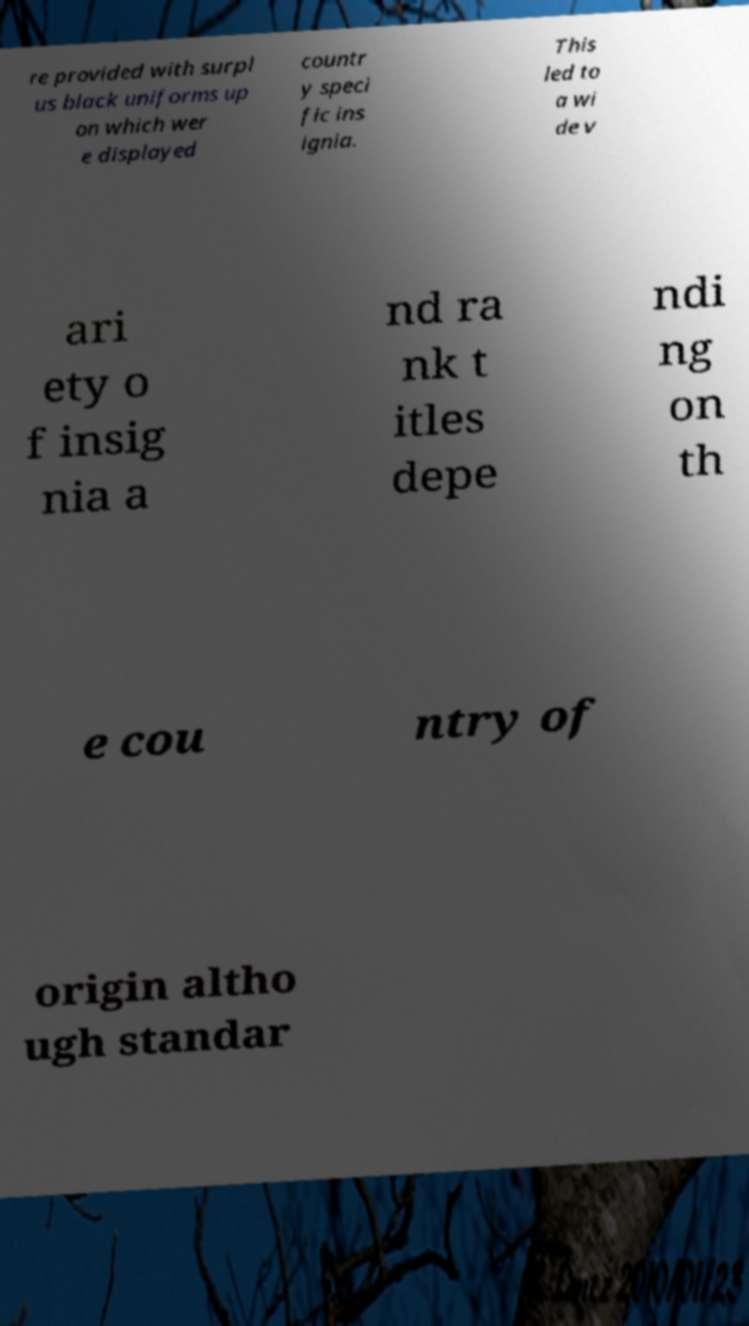What messages or text are displayed in this image? I need them in a readable, typed format. re provided with surpl us black uniforms up on which wer e displayed countr y speci fic ins ignia. This led to a wi de v ari ety o f insig nia a nd ra nk t itles depe ndi ng on th e cou ntry of origin altho ugh standar 